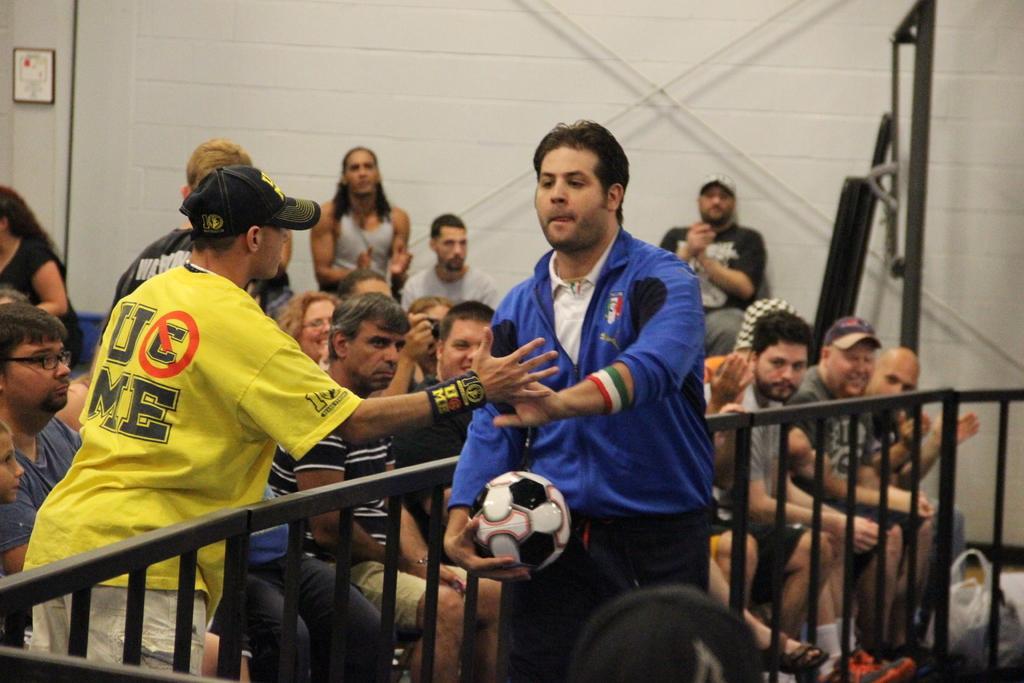Could you give a brief overview of what you see in this image? This picture shows a man holding a ball in his hand, giving hi-fi to the another man wearing a hat. In between them there is a railing. In the background there are some people sitting. And we can observe a wall here. 